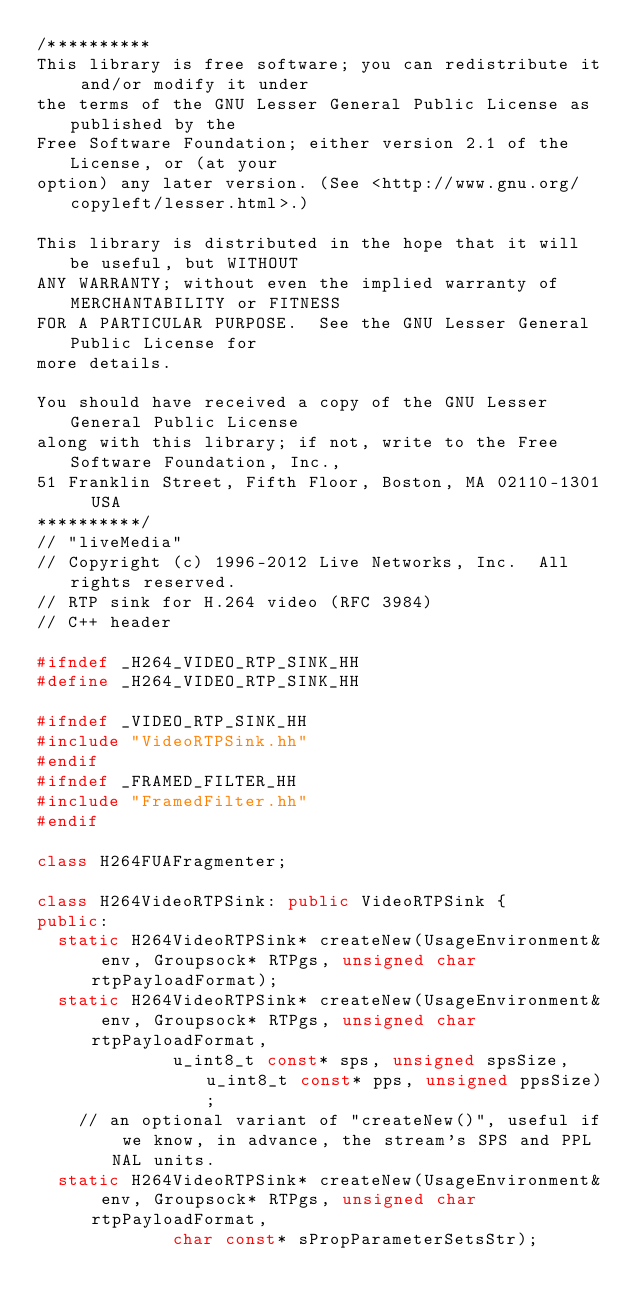Convert code to text. <code><loc_0><loc_0><loc_500><loc_500><_C++_>/**********
This library is free software; you can redistribute it and/or modify it under
the terms of the GNU Lesser General Public License as published by the
Free Software Foundation; either version 2.1 of the License, or (at your
option) any later version. (See <http://www.gnu.org/copyleft/lesser.html>.)

This library is distributed in the hope that it will be useful, but WITHOUT
ANY WARRANTY; without even the implied warranty of MERCHANTABILITY or FITNESS
FOR A PARTICULAR PURPOSE.  See the GNU Lesser General Public License for
more details.

You should have received a copy of the GNU Lesser General Public License
along with this library; if not, write to the Free Software Foundation, Inc.,
51 Franklin Street, Fifth Floor, Boston, MA 02110-1301  USA
**********/
// "liveMedia"
// Copyright (c) 1996-2012 Live Networks, Inc.  All rights reserved.
// RTP sink for H.264 video (RFC 3984)
// C++ header

#ifndef _H264_VIDEO_RTP_SINK_HH
#define _H264_VIDEO_RTP_SINK_HH

#ifndef _VIDEO_RTP_SINK_HH
#include "VideoRTPSink.hh"
#endif
#ifndef _FRAMED_FILTER_HH
#include "FramedFilter.hh"
#endif

class H264FUAFragmenter;

class H264VideoRTPSink: public VideoRTPSink {
public:
  static H264VideoRTPSink* createNew(UsageEnvironment& env, Groupsock* RTPgs, unsigned char rtpPayloadFormat);
  static H264VideoRTPSink* createNew(UsageEnvironment& env, Groupsock* RTPgs, unsigned char rtpPayloadFormat,
				     u_int8_t const* sps, unsigned spsSize, u_int8_t const* pps, unsigned ppsSize);
    // an optional variant of "createNew()", useful if we know, in advance, the stream's SPS and PPL NAL units.
  static H264VideoRTPSink* createNew(UsageEnvironment& env, Groupsock* RTPgs, unsigned char rtpPayloadFormat,
				     char const* sPropParameterSetsStr);</code> 